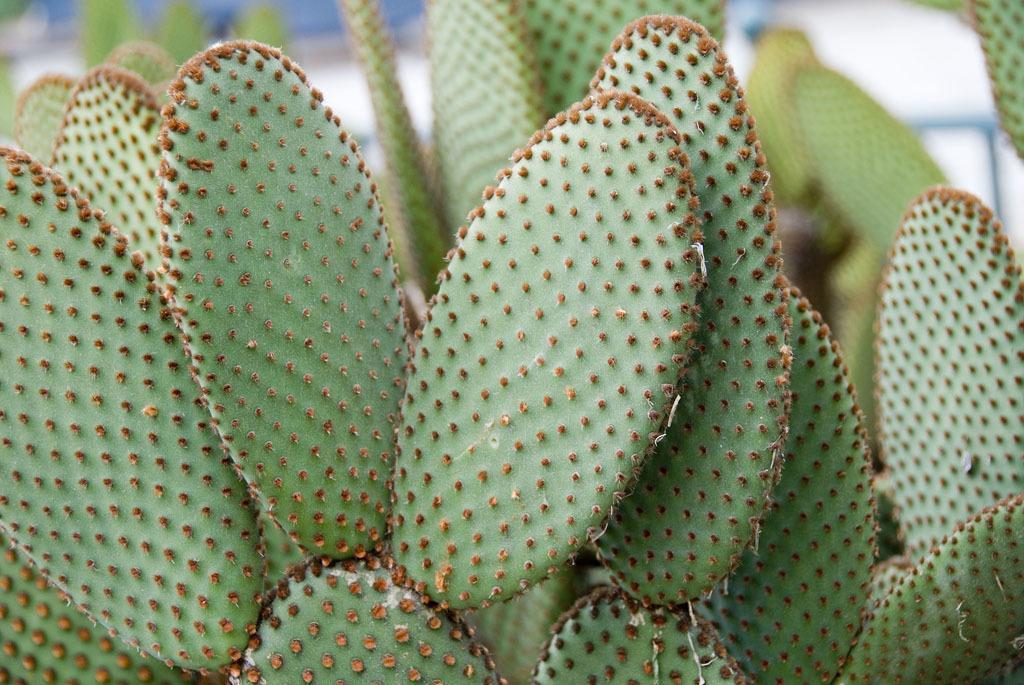Describe this image in one or two sentences. In this image we can see many plants. There is a blur background at the top of the image. 